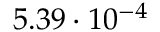<formula> <loc_0><loc_0><loc_500><loc_500>5 . 3 9 \cdot 1 0 ^ { - 4 }</formula> 